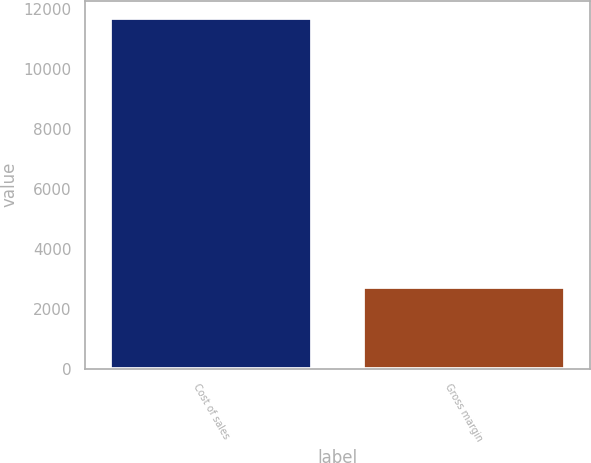Convert chart to OTSL. <chart><loc_0><loc_0><loc_500><loc_500><bar_chart><fcel>Cost of sales<fcel>Gross margin<nl><fcel>11706<fcel>2729<nl></chart> 